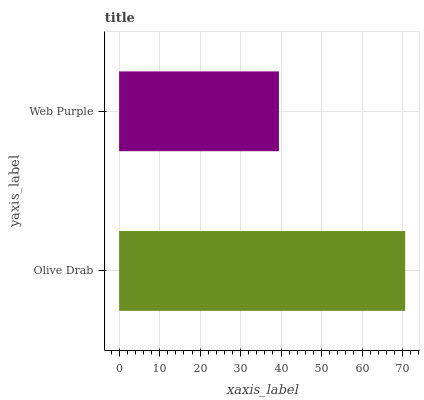Is Web Purple the minimum?
Answer yes or no. Yes. Is Olive Drab the maximum?
Answer yes or no. Yes. Is Web Purple the maximum?
Answer yes or no. No. Is Olive Drab greater than Web Purple?
Answer yes or no. Yes. Is Web Purple less than Olive Drab?
Answer yes or no. Yes. Is Web Purple greater than Olive Drab?
Answer yes or no. No. Is Olive Drab less than Web Purple?
Answer yes or no. No. Is Olive Drab the high median?
Answer yes or no. Yes. Is Web Purple the low median?
Answer yes or no. Yes. Is Web Purple the high median?
Answer yes or no. No. Is Olive Drab the low median?
Answer yes or no. No. 